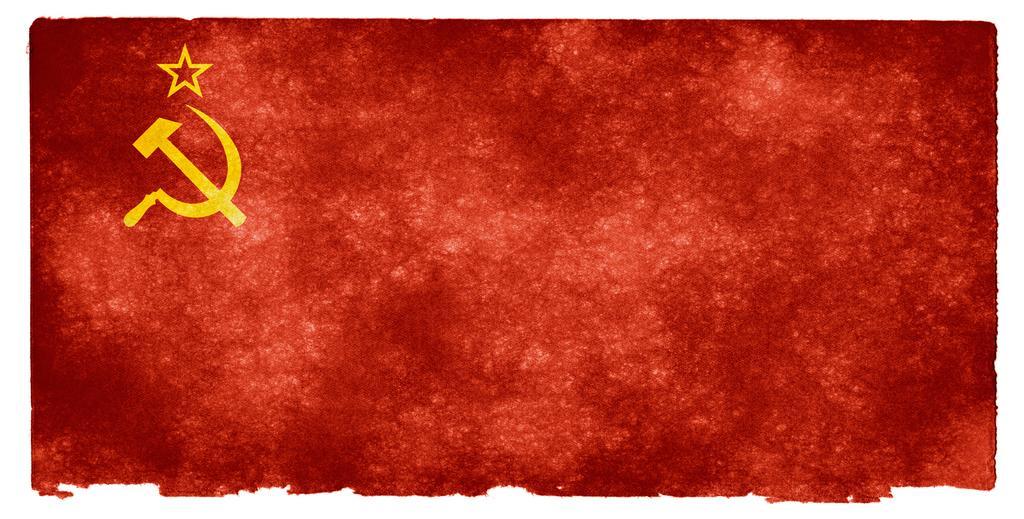Describe this image in one or two sentences. In this image I can see a red color painting. On the left side there is a symbol. 